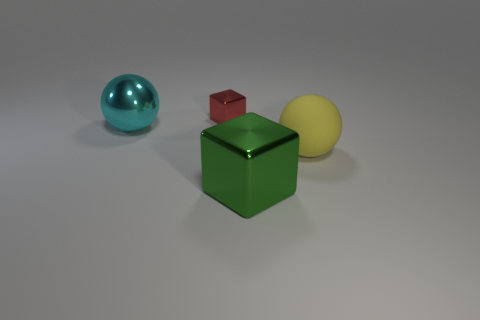The sphere right of the big metal object that is on the right side of the large sphere that is on the left side of the tiny metallic block is made of what material?
Your response must be concise. Rubber. How many things are metallic cubes in front of the red metallic thing or balls that are to the left of the large green cube?
Make the answer very short. 2. There is a yellow object that is the same shape as the cyan thing; what is it made of?
Ensure brevity in your answer.  Rubber. What number of rubber objects are either small red things or big blocks?
Offer a terse response. 0. What shape is the large green object that is made of the same material as the cyan thing?
Make the answer very short. Cube. What number of red shiny objects are the same shape as the green object?
Give a very brief answer. 1. Is the shape of the large object on the right side of the large green block the same as the large thing that is behind the large yellow object?
Provide a succinct answer. Yes. What number of objects are green objects or spheres behind the big yellow object?
Provide a short and direct response. 2. What number of cyan objects have the same size as the cyan metallic sphere?
Your answer should be very brief. 0. How many cyan things are small shiny things or balls?
Make the answer very short. 1. 